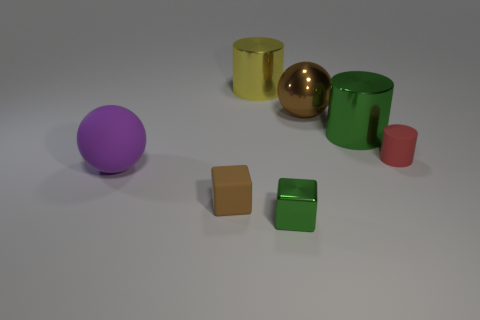Does the yellow cylinder have the same size as the green object that is behind the tiny red thing?
Your response must be concise. Yes. How many other things are the same material as the brown cube?
Your response must be concise. 2. How many objects are cylinders on the right side of the brown metallic object or purple objects behind the brown matte block?
Offer a very short reply. 3. What material is the purple thing that is the same shape as the brown shiny object?
Make the answer very short. Rubber. Is there a big red object?
Provide a short and direct response. No. There is a thing that is to the left of the matte cylinder and on the right side of the large brown ball; what size is it?
Give a very brief answer. Large. There is a big yellow metal object; what shape is it?
Provide a short and direct response. Cylinder. Is there a green cube that is to the left of the tiny rubber thing to the left of the yellow object?
Offer a terse response. No. What material is the brown thing that is the same size as the matte cylinder?
Provide a short and direct response. Rubber. Are there any other cylinders that have the same size as the green metallic cylinder?
Offer a terse response. Yes. 